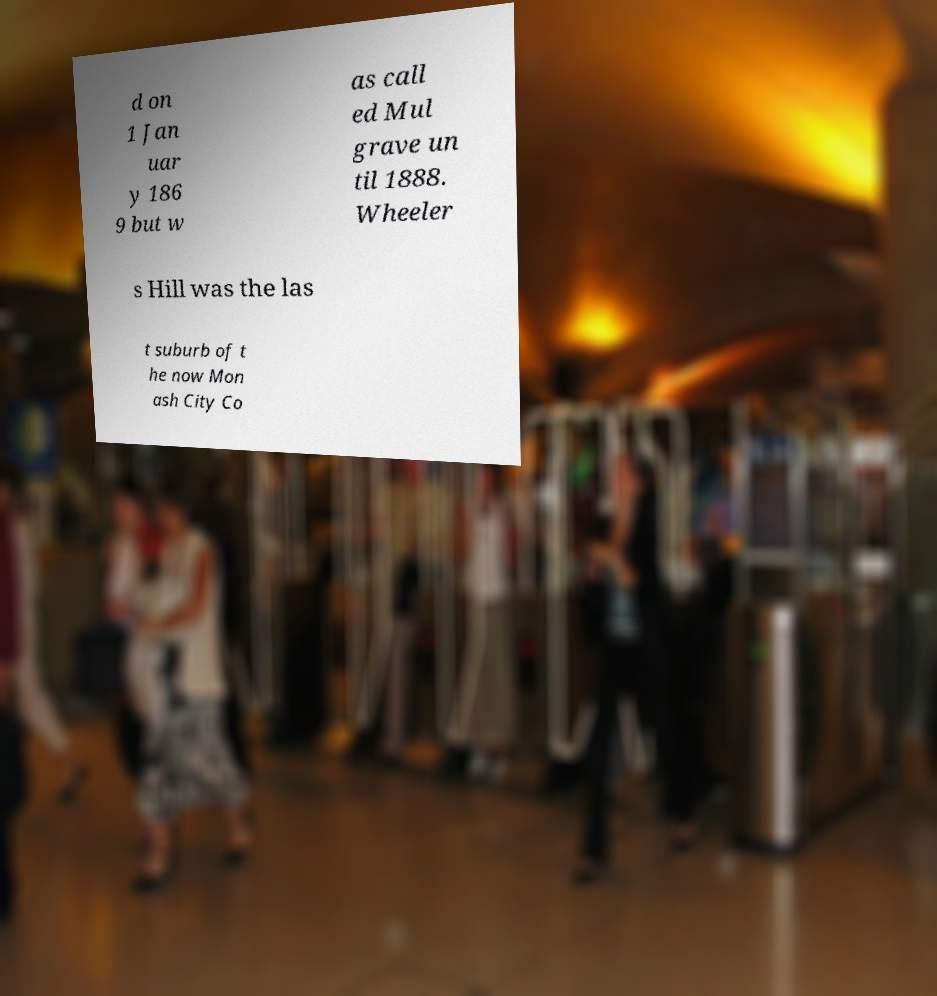Can you accurately transcribe the text from the provided image for me? d on 1 Jan uar y 186 9 but w as call ed Mul grave un til 1888. Wheeler s Hill was the las t suburb of t he now Mon ash City Co 